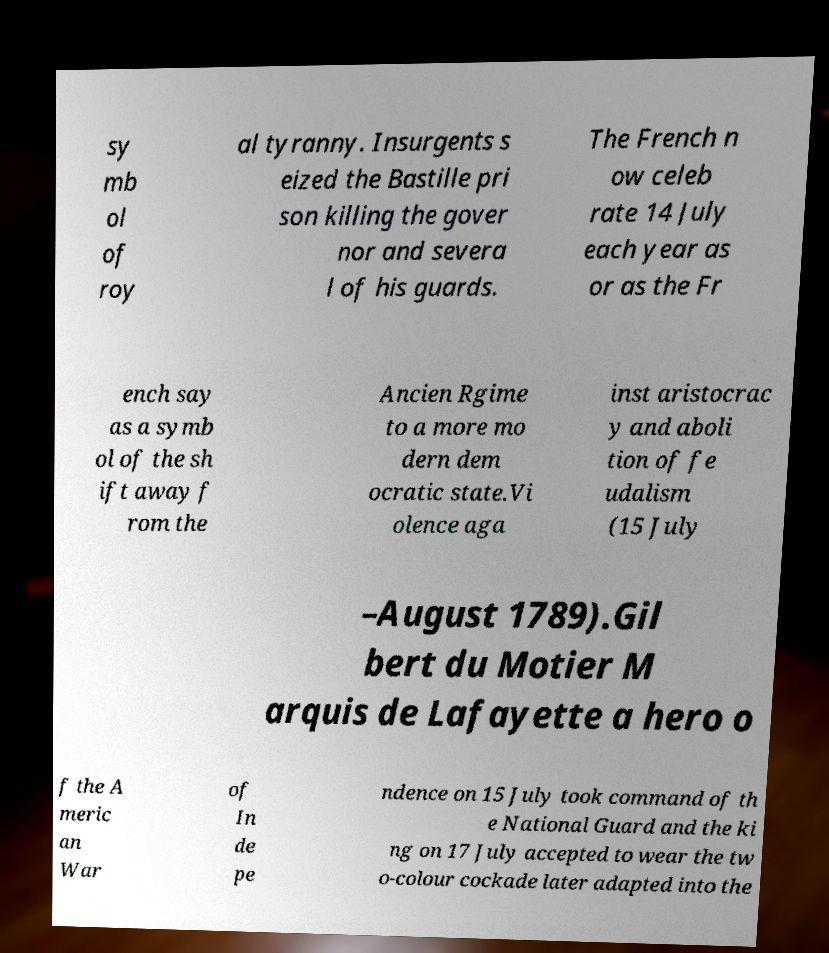What messages or text are displayed in this image? I need them in a readable, typed format. sy mb ol of roy al tyranny. Insurgents s eized the Bastille pri son killing the gover nor and severa l of his guards. The French n ow celeb rate 14 July each year as or as the Fr ench say as a symb ol of the sh ift away f rom the Ancien Rgime to a more mo dern dem ocratic state.Vi olence aga inst aristocrac y and aboli tion of fe udalism (15 July –August 1789).Gil bert du Motier M arquis de Lafayette a hero o f the A meric an War of In de pe ndence on 15 July took command of th e National Guard and the ki ng on 17 July accepted to wear the tw o-colour cockade later adapted into the 